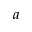Convert formula to latex. <formula><loc_0><loc_0><loc_500><loc_500>a</formula> 